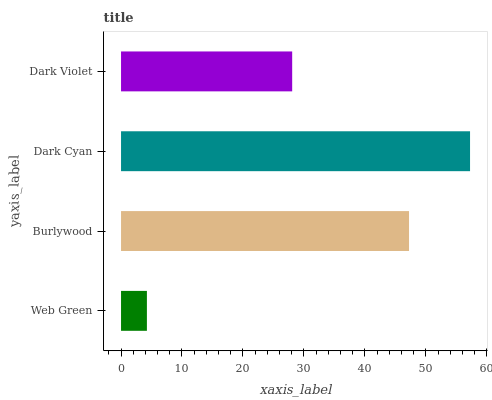Is Web Green the minimum?
Answer yes or no. Yes. Is Dark Cyan the maximum?
Answer yes or no. Yes. Is Burlywood the minimum?
Answer yes or no. No. Is Burlywood the maximum?
Answer yes or no. No. Is Burlywood greater than Web Green?
Answer yes or no. Yes. Is Web Green less than Burlywood?
Answer yes or no. Yes. Is Web Green greater than Burlywood?
Answer yes or no. No. Is Burlywood less than Web Green?
Answer yes or no. No. Is Burlywood the high median?
Answer yes or no. Yes. Is Dark Violet the low median?
Answer yes or no. Yes. Is Dark Cyan the high median?
Answer yes or no. No. Is Web Green the low median?
Answer yes or no. No. 